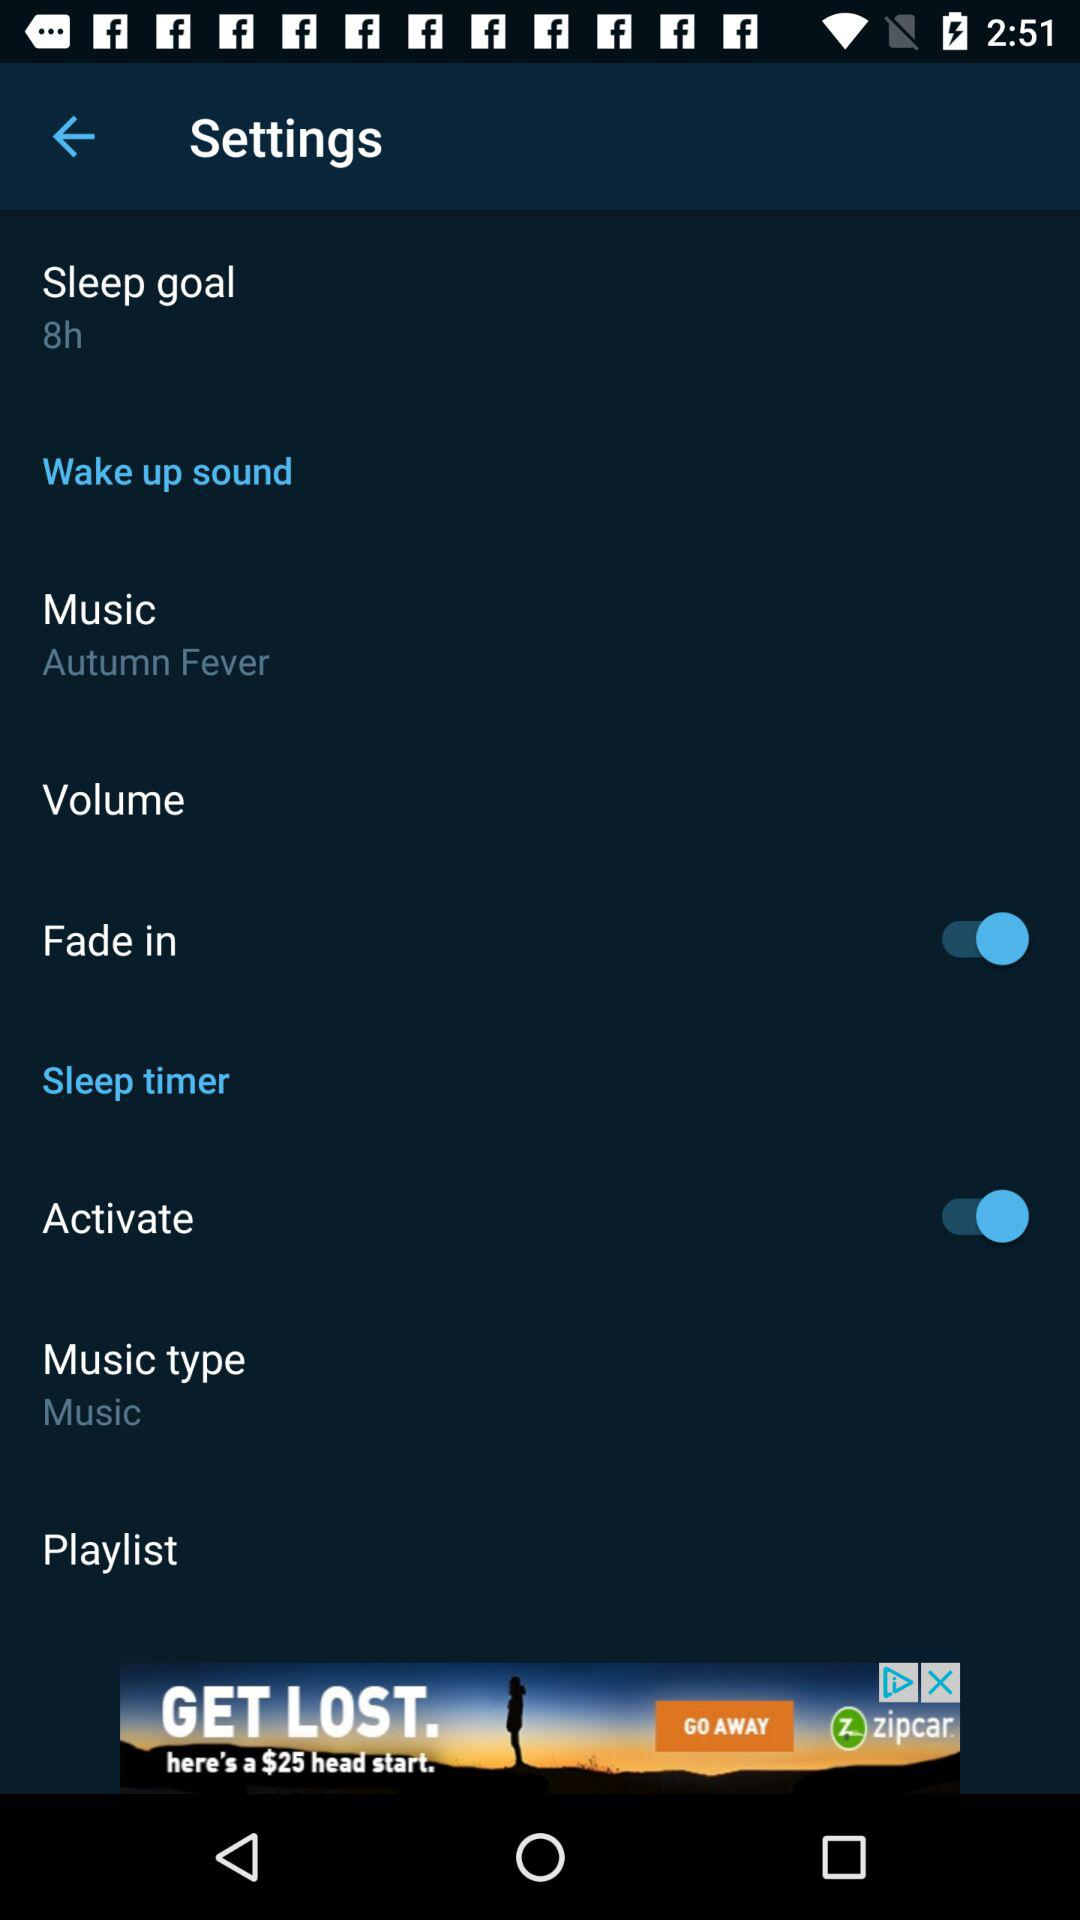What is the status of the "Fade in"? The status is "on". 